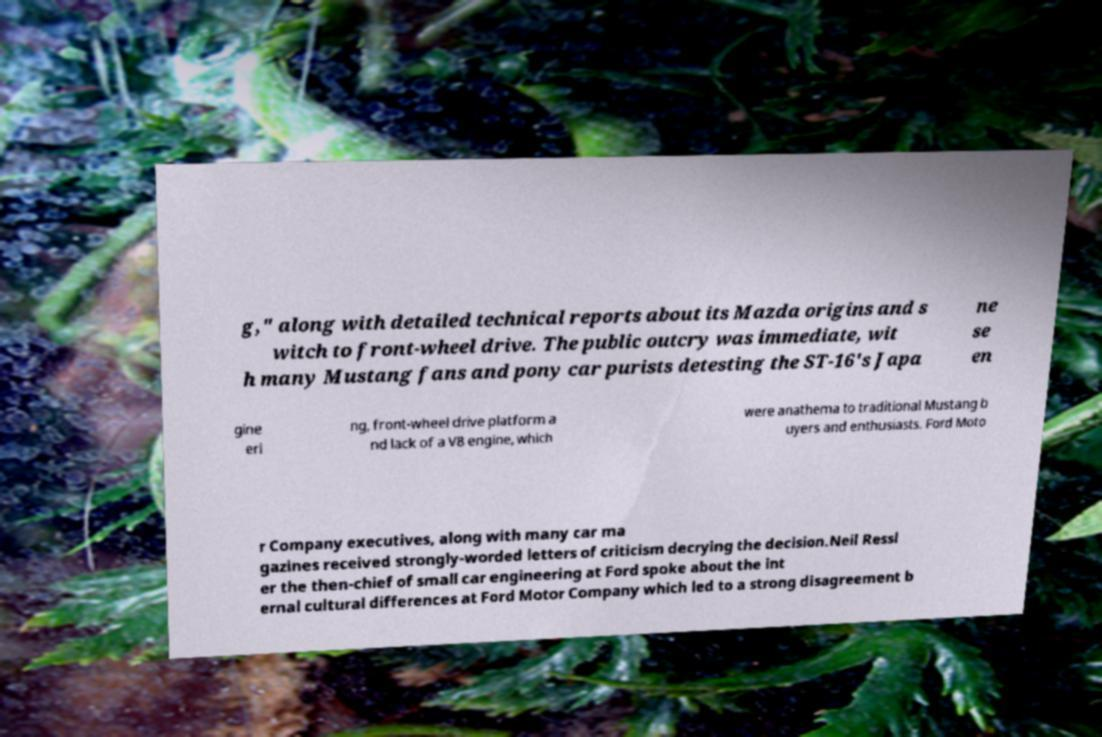Can you read and provide the text displayed in the image?This photo seems to have some interesting text. Can you extract and type it out for me? g," along with detailed technical reports about its Mazda origins and s witch to front-wheel drive. The public outcry was immediate, wit h many Mustang fans and pony car purists detesting the ST-16's Japa ne se en gine eri ng, front-wheel drive platform a nd lack of a V8 engine, which were anathema to traditional Mustang b uyers and enthusiasts. Ford Moto r Company executives, along with many car ma gazines received strongly-worded letters of criticism decrying the decision.Neil Ressl er the then-chief of small car engineering at Ford spoke about the int ernal cultural differences at Ford Motor Company which led to a strong disagreement b 